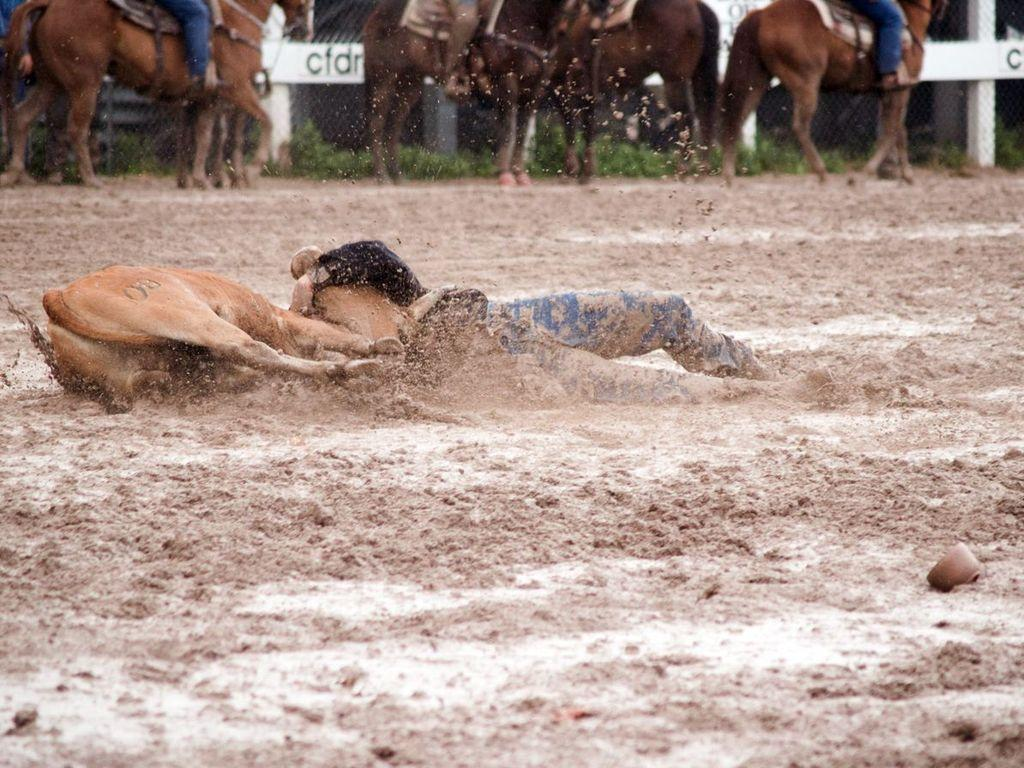Who or what can be seen in the image? There is a person and an animal in the image. What are the person and the animal doing in the image? Both the person and the animal are falling in the mud. Are there any other animals present in the image? Yes, there are horses in the image. What can be seen in the background of the image? There is a fence in the image. What type of prison can be seen in the image? There is no prison present in the image. What shape is the canvas in the image? There is no canvas present in the image. 